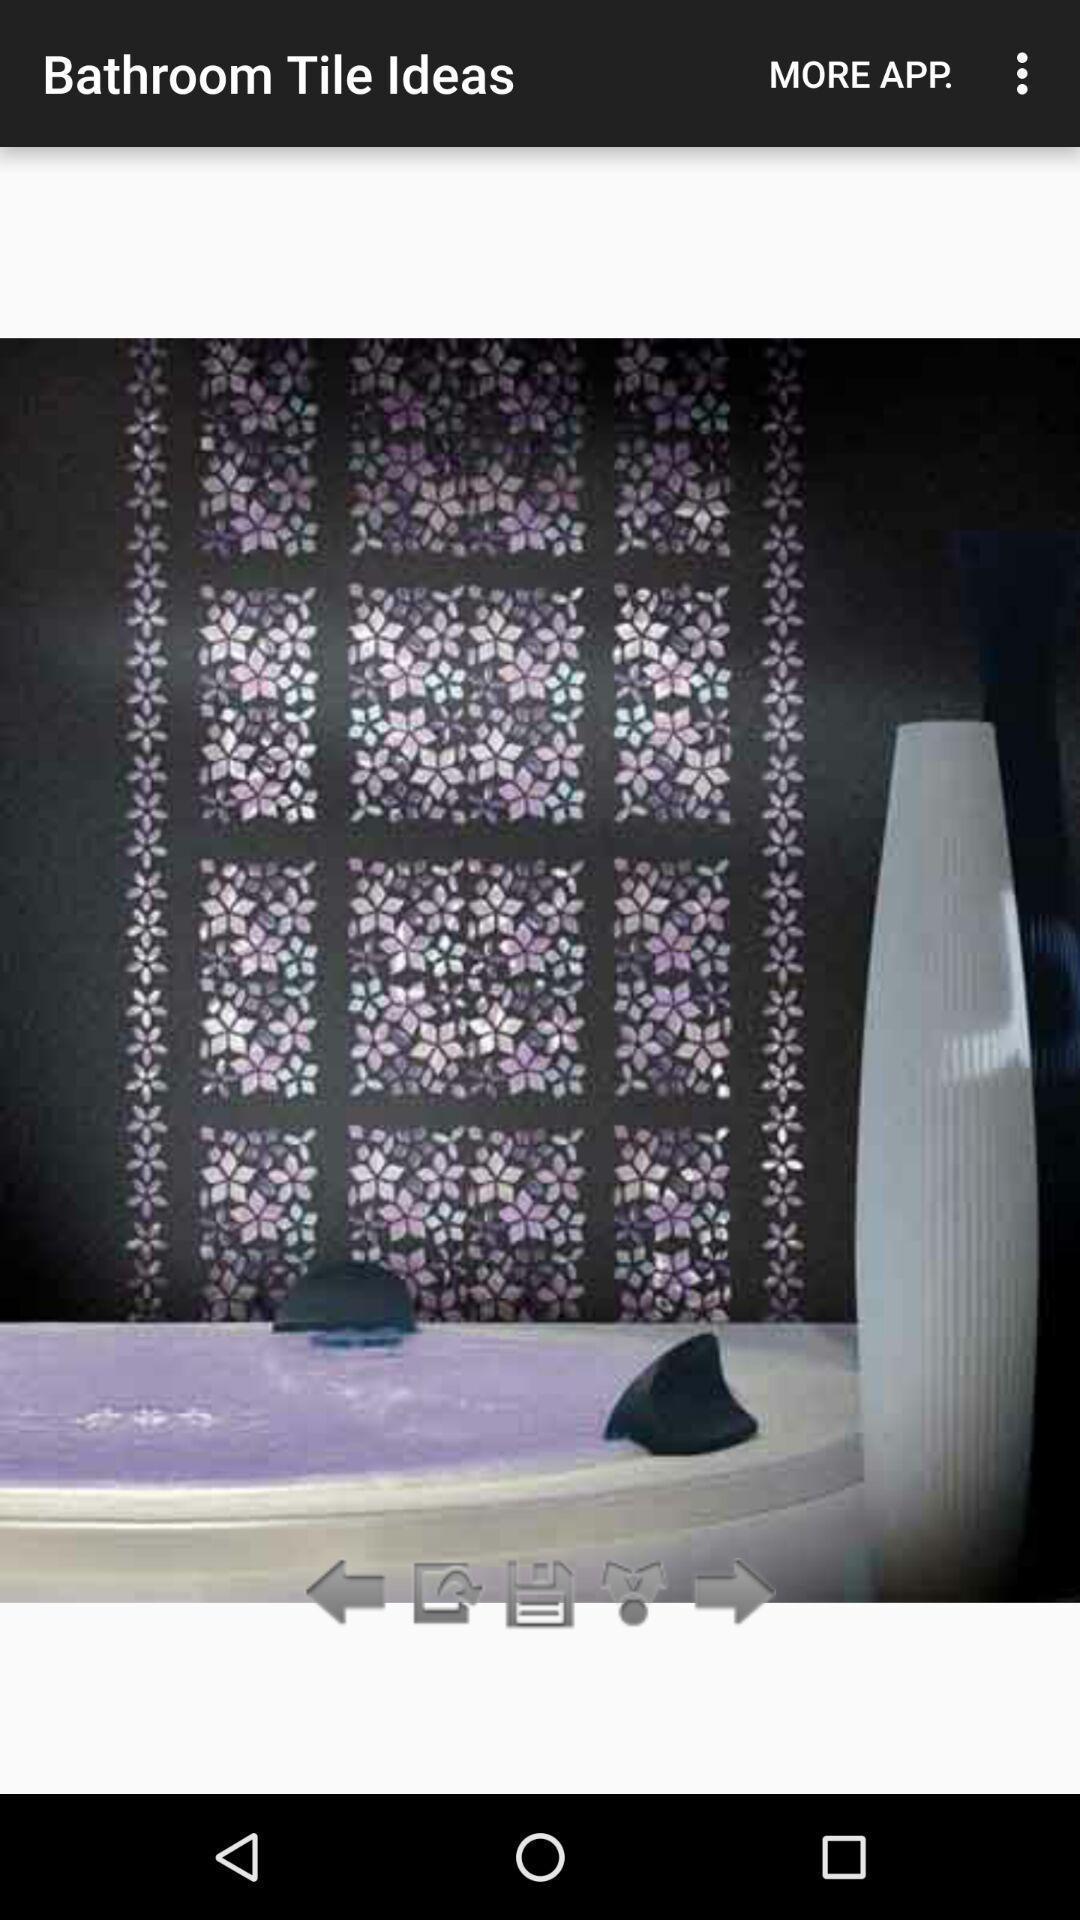Summarize the information in this screenshot. Screen showing image for tile ideas. 